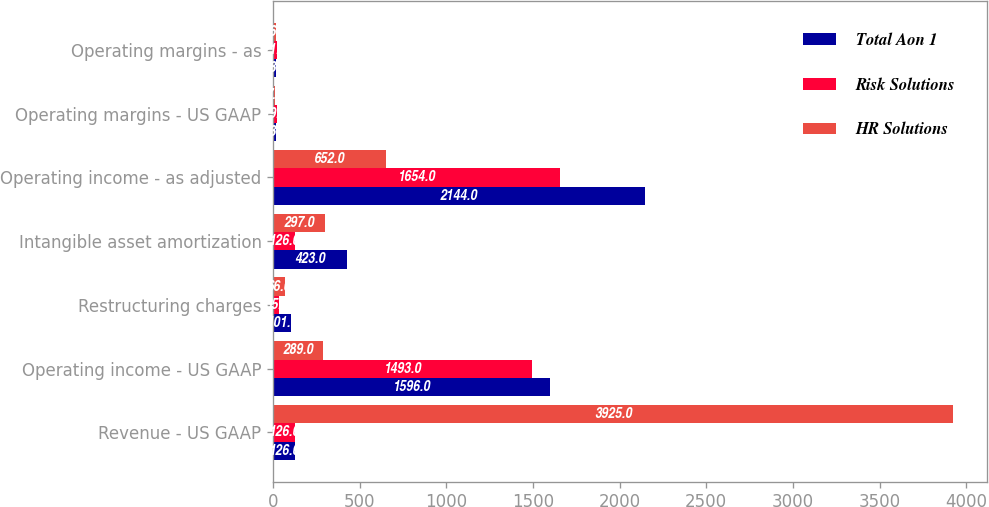<chart> <loc_0><loc_0><loc_500><loc_500><stacked_bar_chart><ecel><fcel>Revenue - US GAAP<fcel>Operating income - US GAAP<fcel>Restructuring charges<fcel>Intangible asset amortization<fcel>Operating income - as adjusted<fcel>Operating margins - US GAAP<fcel>Operating margins - as<nl><fcel>Total Aon 1<fcel>126<fcel>1596<fcel>101<fcel>423<fcel>2144<fcel>13.9<fcel>18.6<nl><fcel>Risk Solutions<fcel>126<fcel>1493<fcel>35<fcel>126<fcel>1654<fcel>19.6<fcel>21.7<nl><fcel>HR Solutions<fcel>3925<fcel>289<fcel>66<fcel>297<fcel>652<fcel>7.4<fcel>16.6<nl></chart> 